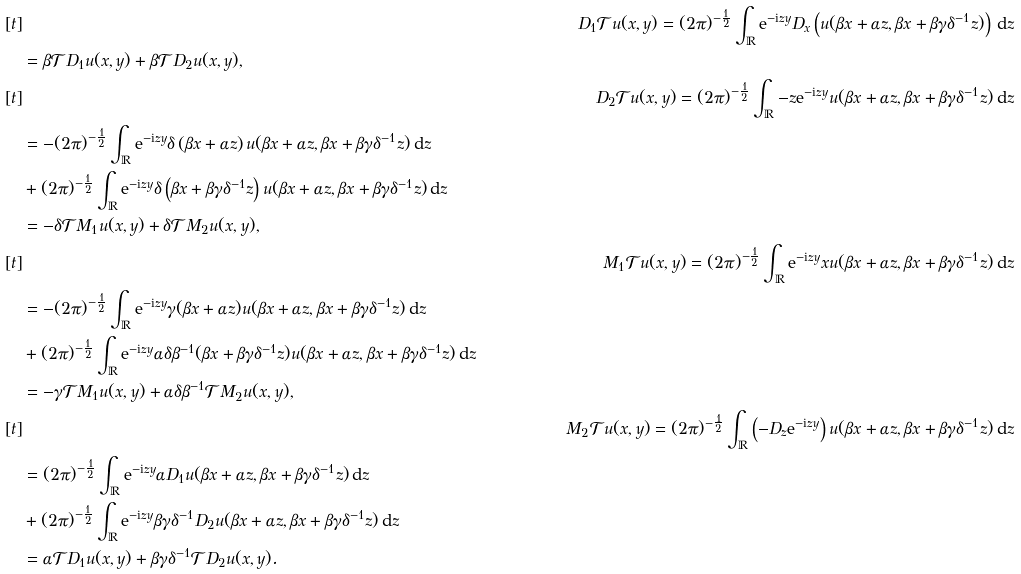<formula> <loc_0><loc_0><loc_500><loc_500>& [ t ] & D _ { 1 } \mathcal { T } u ( x , y ) = ( 2 \pi ) ^ { - \frac { 1 } { 2 } } \int _ { \mathbb { R } } \mathrm e ^ { - \mathrm i z y } D _ { x } \left ( u ( \beta x + \alpha z , \beta x + \beta \gamma \delta ^ { - 1 } z ) \right ) \, \mathrm d z \\ & \quad = \beta \mathcal { T } D _ { 1 } u ( x , y ) + \beta \mathcal { T } D _ { 2 } u ( x , y ) , \\ & [ t ] & D _ { 2 } \mathcal { T } u ( x , y ) = ( 2 \pi ) ^ { - \frac { 1 } { 2 } } \int _ { \mathbb { R } } - z \mathrm e ^ { - \mathrm i z y } u ( \beta x + \alpha z , \beta x + \beta \gamma \delta ^ { - 1 } z ) \, \mathrm d z \\ & \quad = - ( 2 \pi ) ^ { - \frac { 1 } { 2 } } \int _ { \mathbb { R } } \mathrm e ^ { - \mathrm i z y } \delta \left ( \beta x + \alpha z \right ) u ( \beta x + \alpha z , \beta x + \beta \gamma \delta ^ { - 1 } z ) \, \mathrm d z \\ & \quad + ( 2 \pi ) ^ { - \frac { 1 } { 2 } } \int _ { \mathbb { R } } \mathrm e ^ { - \mathrm i z y } \delta \left ( \beta x + \beta \gamma \delta ^ { - 1 } z \right ) u ( \beta x + \alpha z , \beta x + \beta \gamma \delta ^ { - 1 } z ) \, \mathrm d z \\ & \quad = - \delta \mathcal { T } M _ { 1 } u ( x , y ) + \delta \mathcal { T } M _ { 2 } u ( x , y ) , \\ & [ t ] & M _ { 1 } \mathcal { T } u ( x , y ) = ( 2 \pi ) ^ { - \frac { 1 } { 2 } } \int _ { \mathbb { R } } \mathrm e ^ { - \mathrm i z y } x u ( \beta x + \alpha z , \beta x + \beta \gamma \delta ^ { - 1 } z ) \, \mathrm d z \\ & \quad = - ( 2 \pi ) ^ { - \frac { 1 } { 2 } } \int _ { \mathbb { R } } \mathrm e ^ { - \mathrm i z y } \gamma ( \beta x + \alpha z ) u ( \beta x + \alpha z , \beta x + \beta \gamma \delta ^ { - 1 } z ) \, \mathrm d z \\ & \quad + ( 2 \pi ) ^ { - \frac { 1 } { 2 } } \int _ { \mathbb { R } } \mathrm e ^ { - \mathrm i z y } \alpha \delta \beta ^ { - 1 } ( \beta x + \beta \gamma \delta ^ { - 1 } z ) u ( \beta x + \alpha z , \beta x + \beta \gamma \delta ^ { - 1 } z ) \, \mathrm d z \\ & \quad = - \gamma \mathcal { T } M _ { 1 } u ( x , y ) + \alpha \delta \beta ^ { - 1 } \mathcal { T } M _ { 2 } u ( x , y ) , \\ & [ t ] & M _ { 2 } \mathcal { T } u ( x , y ) = ( 2 \pi ) ^ { - \frac { 1 } { 2 } } \int _ { \mathbb { R } } \left ( - D _ { z } \mathrm e ^ { - \mathrm i z y } \right ) u ( \beta x + \alpha z , \beta x + \beta \gamma \delta ^ { - 1 } z ) \, \mathrm d z \\ & \quad = ( 2 \pi ) ^ { - \frac { 1 } { 2 } } \int _ { \mathbb { R } } \mathrm e ^ { - \mathrm i z y } \alpha D _ { 1 } u ( \beta x + \alpha z , \beta x + \beta \gamma \delta ^ { - 1 } z ) \, \mathrm d z \\ & \quad + ( 2 \pi ) ^ { - \frac { 1 } { 2 } } \int _ { \mathbb { R } } \mathrm e ^ { - \mathrm i z y } \beta \gamma \delta ^ { - 1 } D _ { 2 } u ( \beta x + \alpha z , \beta x + \beta \gamma \delta ^ { - 1 } z ) \, \mathrm d z \\ & \quad = \alpha \mathcal { T } D _ { 1 } u ( x , y ) + \beta \gamma \delta ^ { - 1 } \mathcal { T } D _ { 2 } u ( x , y ) .</formula> 